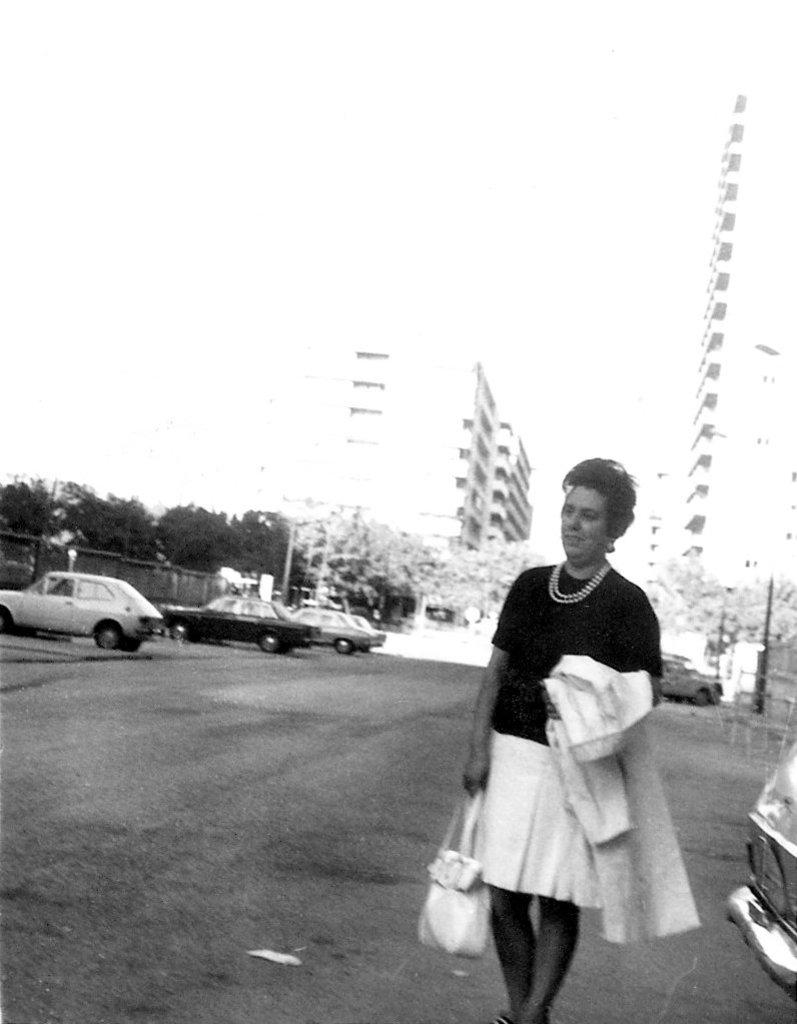Who is present in the image? There is a lady in the image. Where is the lady located in the image? The lady is on the right side of the image. What is the lady holding in the image? The lady is holding a bag. What can be seen in the background of the image? There are buildings, trees, cars, and poles in the background of the image. What type of hands can be seen holding the bag in the image? There is no mention of hands holding the bag in the image; it only states that the lady is holding a bag. 